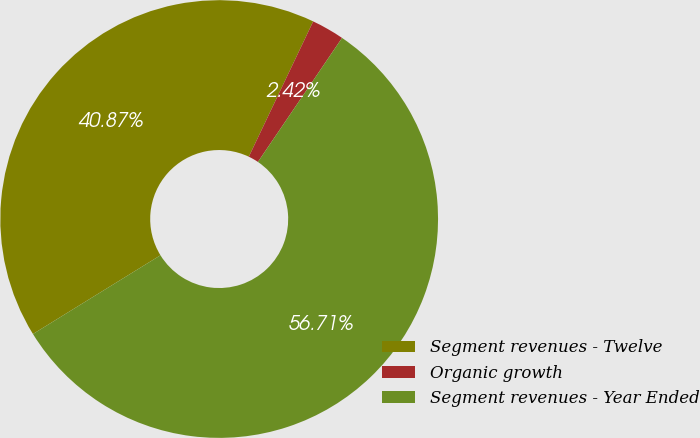Convert chart to OTSL. <chart><loc_0><loc_0><loc_500><loc_500><pie_chart><fcel>Segment revenues - Twelve<fcel>Organic growth<fcel>Segment revenues - Year Ended<nl><fcel>40.87%<fcel>2.42%<fcel>56.71%<nl></chart> 